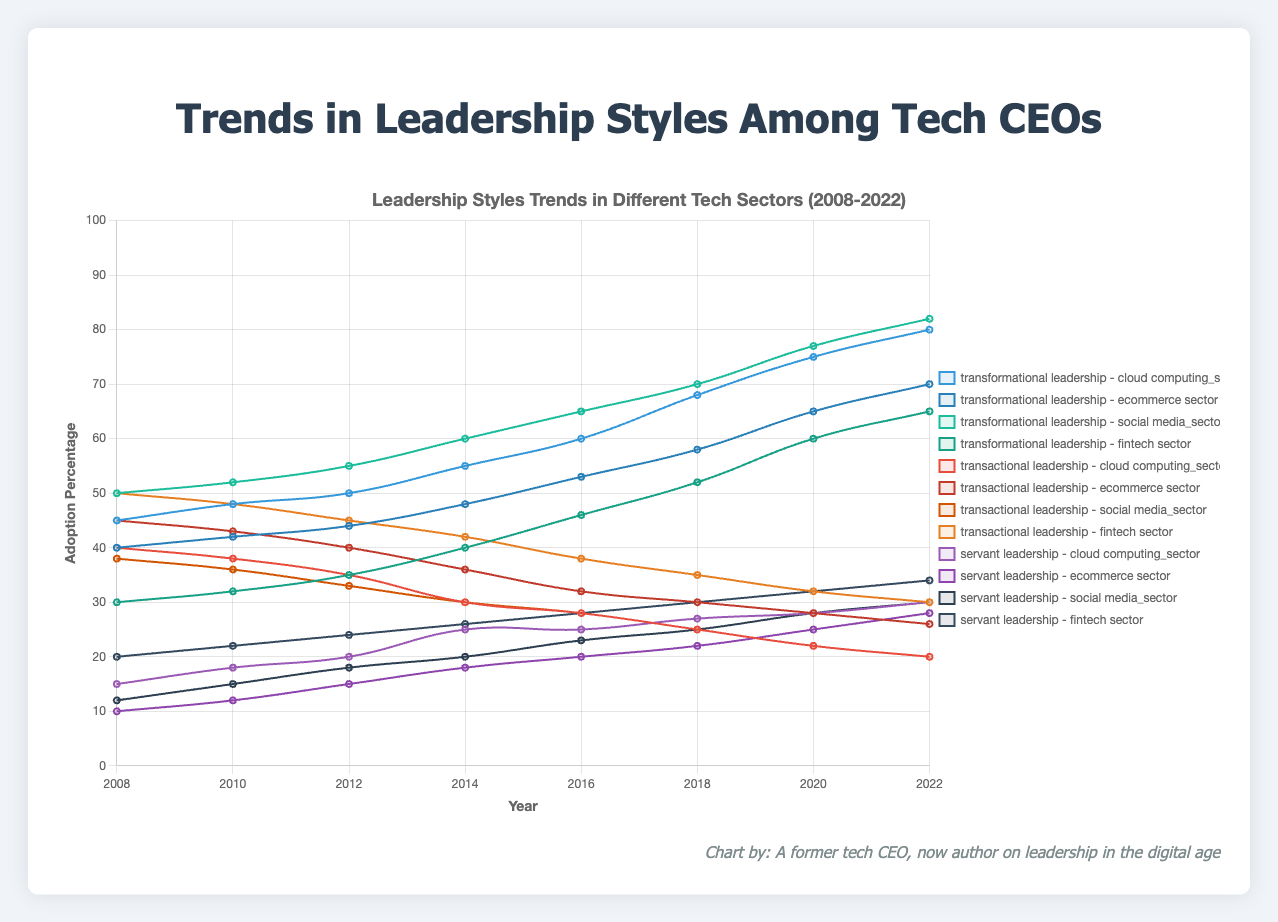What sector showed the highest increase in transformational leadership from 2008 to 2022? By examining the trend lines for transformational leadership, we need to identify the sector with the greatest increase from 2008 to 2022. The lines indicate the following increases: cloud computing (35%), ecommerce (30%), social media (32%), fintech (35%). Both cloud computing and fintech sectors show the highest increase of 35%.
Answer: Cloud computing and fintech Which sector had the highest percentage of transformational leadership in 2022? Refer to the end points of the transformational leadership lines in 2022. The values for 2022 are: cloud computing (80%), ecommerce (70%), social media (82%), fintech (65%). Social media has the highest percentage of 82%.
Answer: Social media In which sector did transactional leadership decrease the most over the 15 years? Calculate the difference in transactional leadership from 2008 to 2022 for each sector. The differences are: cloud computing (20%), ecommerce (19%), social media (18%), fintech (20%). Both cloud computing and fintech sectors indicate the largest decrease of 20%.
Answer: Cloud computing and fintech What is the average percentage of servant leadership across all sectors in 2018? Add the servant leadership percentages for each sector in 2018 and divide by the number of sectors: (27 + 22 + 25 + 30)/4 = 26
Answer: 26 Which two sectors had the same percentage of transactional leadership in 2012? Compare the transactional leadership percentages in 2012: cloud computing (35%), ecommerce (40%), social media (33%), fintech (45%). No sectors have the same percentage.
Answer: None What leadership style had the lowest adoption in the ecommerce sector in 2008? Identify the 2008 values for the ecommerce sector: transformational (40%), transactional (45%), servant (10%). Servant leadership had the lowest adoption at 10%.
Answer: Servant leadership Did any sector surpass 80% adoption in transformational leadership by 2022? Check the transformational leadership values in 2022 for each sector: cloud computing (80%), ecommerce (70%), social media (82%), fintech (65%). Social media surpassed 80%.
Answer: Social media What is the total percentage of transactional and servant leadership in the fintech sector in 2014? Sum the percentages of transactional and servant leadership in fintech in 2014: 42 + 26 = 68
Answer: 68 